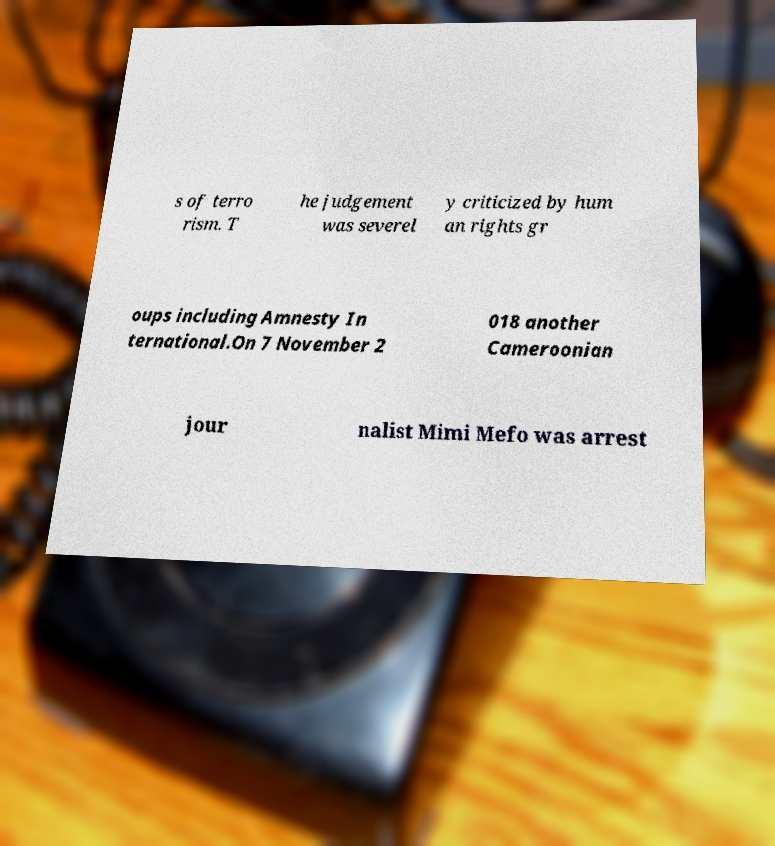Please read and relay the text visible in this image. What does it say? s of terro rism. T he judgement was severel y criticized by hum an rights gr oups including Amnesty In ternational.On 7 November 2 018 another Cameroonian jour nalist Mimi Mefo was arrest 